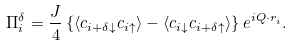<formula> <loc_0><loc_0><loc_500><loc_500>\Pi _ { i } ^ { \delta } = \frac { J } { 4 } \left \{ \langle c _ { i + \delta \downarrow } c _ { i \uparrow } \rangle - \langle c _ { i \downarrow } c _ { i + \delta \uparrow } \rangle \right \} e ^ { i { Q \cdot r } _ { i } } .</formula> 